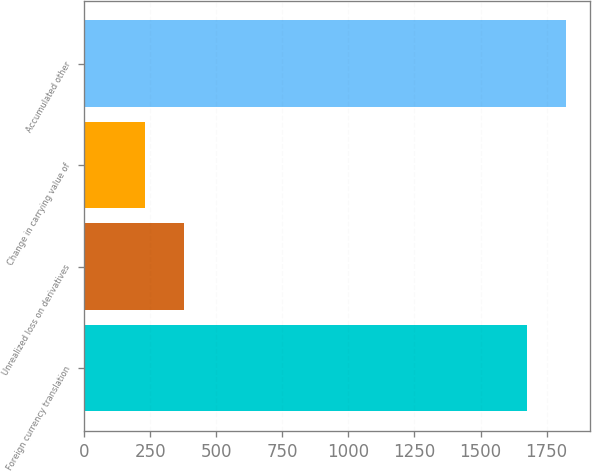<chart> <loc_0><loc_0><loc_500><loc_500><bar_chart><fcel>Foreign currency translation<fcel>Unrealized loss on derivatives<fcel>Change in carrying value of<fcel>Accumulated other<nl><fcel>1677<fcel>378.9<fcel>232<fcel>1823.9<nl></chart> 